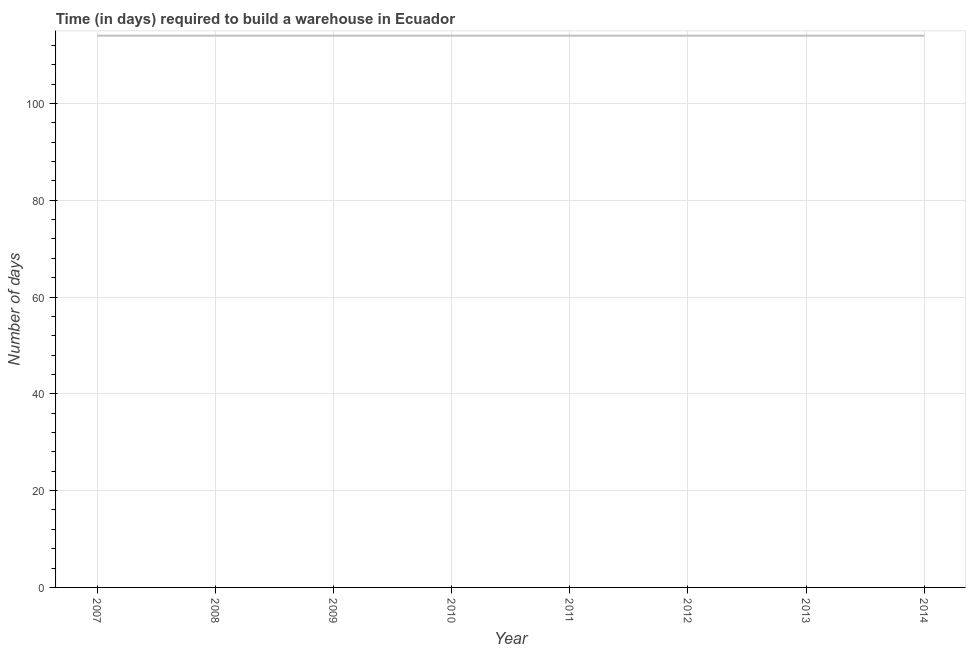What is the time required to build a warehouse in 2012?
Give a very brief answer. 114. Across all years, what is the maximum time required to build a warehouse?
Provide a short and direct response. 114. Across all years, what is the minimum time required to build a warehouse?
Your answer should be very brief. 114. In which year was the time required to build a warehouse minimum?
Ensure brevity in your answer.  2007. What is the sum of the time required to build a warehouse?
Keep it short and to the point. 912. What is the average time required to build a warehouse per year?
Give a very brief answer. 114. What is the median time required to build a warehouse?
Keep it short and to the point. 114. Do a majority of the years between 2009 and 2011 (inclusive) have time required to build a warehouse greater than 60 days?
Ensure brevity in your answer.  Yes. What is the ratio of the time required to build a warehouse in 2012 to that in 2014?
Your answer should be compact. 1. Is the time required to build a warehouse in 2008 less than that in 2011?
Make the answer very short. No. Is the difference between the time required to build a warehouse in 2008 and 2013 greater than the difference between any two years?
Ensure brevity in your answer.  Yes. What is the difference between the highest and the second highest time required to build a warehouse?
Provide a short and direct response. 0. Is the sum of the time required to build a warehouse in 2007 and 2010 greater than the maximum time required to build a warehouse across all years?
Your response must be concise. Yes. What is the difference between the highest and the lowest time required to build a warehouse?
Your answer should be very brief. 0. Does the time required to build a warehouse monotonically increase over the years?
Your answer should be very brief. No. How many years are there in the graph?
Your answer should be very brief. 8. What is the difference between two consecutive major ticks on the Y-axis?
Your answer should be very brief. 20. What is the title of the graph?
Your answer should be very brief. Time (in days) required to build a warehouse in Ecuador. What is the label or title of the X-axis?
Give a very brief answer. Year. What is the label or title of the Y-axis?
Give a very brief answer. Number of days. What is the Number of days of 2007?
Offer a very short reply. 114. What is the Number of days in 2008?
Provide a succinct answer. 114. What is the Number of days of 2009?
Offer a terse response. 114. What is the Number of days of 2010?
Give a very brief answer. 114. What is the Number of days of 2011?
Your answer should be compact. 114. What is the Number of days in 2012?
Keep it short and to the point. 114. What is the Number of days in 2013?
Make the answer very short. 114. What is the Number of days in 2014?
Make the answer very short. 114. What is the difference between the Number of days in 2007 and 2010?
Offer a very short reply. 0. What is the difference between the Number of days in 2007 and 2011?
Make the answer very short. 0. What is the difference between the Number of days in 2007 and 2012?
Ensure brevity in your answer.  0. What is the difference between the Number of days in 2007 and 2014?
Your answer should be compact. 0. What is the difference between the Number of days in 2008 and 2009?
Your answer should be very brief. 0. What is the difference between the Number of days in 2008 and 2010?
Your response must be concise. 0. What is the difference between the Number of days in 2008 and 2011?
Ensure brevity in your answer.  0. What is the difference between the Number of days in 2008 and 2013?
Give a very brief answer. 0. What is the difference between the Number of days in 2008 and 2014?
Provide a short and direct response. 0. What is the difference between the Number of days in 2009 and 2011?
Your answer should be very brief. 0. What is the difference between the Number of days in 2009 and 2012?
Keep it short and to the point. 0. What is the difference between the Number of days in 2009 and 2013?
Keep it short and to the point. 0. What is the difference between the Number of days in 2011 and 2012?
Give a very brief answer. 0. What is the difference between the Number of days in 2011 and 2013?
Provide a short and direct response. 0. What is the difference between the Number of days in 2011 and 2014?
Ensure brevity in your answer.  0. What is the difference between the Number of days in 2012 and 2013?
Your answer should be compact. 0. What is the difference between the Number of days in 2012 and 2014?
Offer a terse response. 0. What is the ratio of the Number of days in 2007 to that in 2008?
Make the answer very short. 1. What is the ratio of the Number of days in 2007 to that in 2010?
Your answer should be compact. 1. What is the ratio of the Number of days in 2008 to that in 2009?
Provide a succinct answer. 1. What is the ratio of the Number of days in 2008 to that in 2010?
Offer a very short reply. 1. What is the ratio of the Number of days in 2008 to that in 2011?
Offer a terse response. 1. What is the ratio of the Number of days in 2008 to that in 2012?
Give a very brief answer. 1. What is the ratio of the Number of days in 2008 to that in 2014?
Your answer should be compact. 1. What is the ratio of the Number of days in 2009 to that in 2011?
Offer a terse response. 1. What is the ratio of the Number of days in 2009 to that in 2012?
Keep it short and to the point. 1. What is the ratio of the Number of days in 2009 to that in 2013?
Give a very brief answer. 1. What is the ratio of the Number of days in 2009 to that in 2014?
Ensure brevity in your answer.  1. What is the ratio of the Number of days in 2010 to that in 2014?
Your response must be concise. 1. What is the ratio of the Number of days in 2011 to that in 2013?
Keep it short and to the point. 1. What is the ratio of the Number of days in 2011 to that in 2014?
Keep it short and to the point. 1. What is the ratio of the Number of days in 2012 to that in 2014?
Offer a very short reply. 1. What is the ratio of the Number of days in 2013 to that in 2014?
Give a very brief answer. 1. 